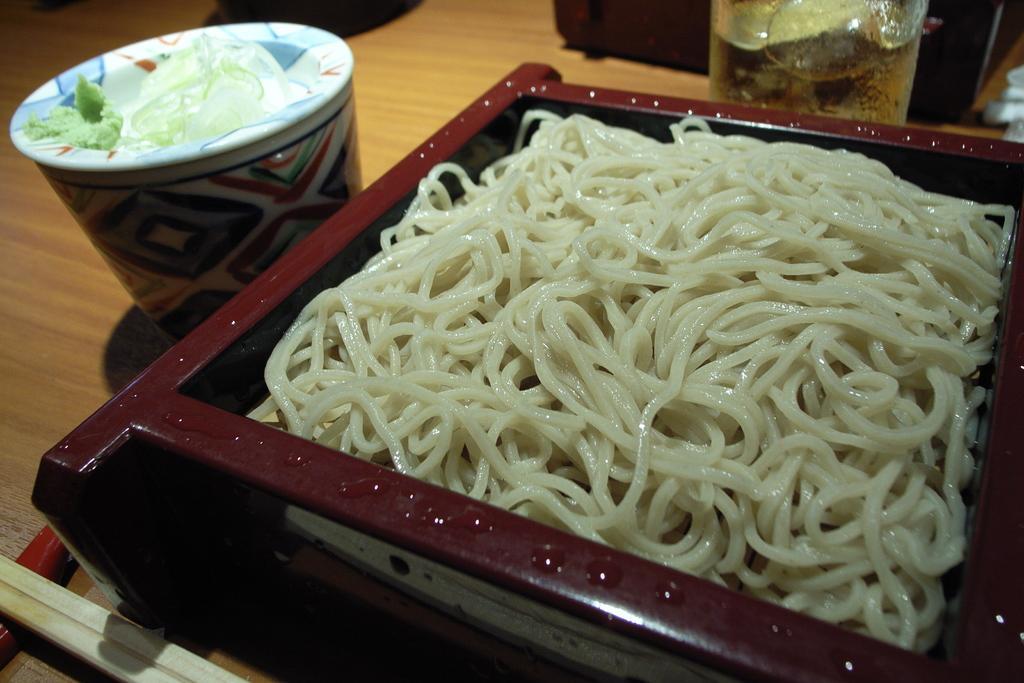Can you describe this image briefly? On the right side, there are white color noodles placed in a bowl. This bowl is placed on a wooden table, on which there is a cup, a glass and other objects. 